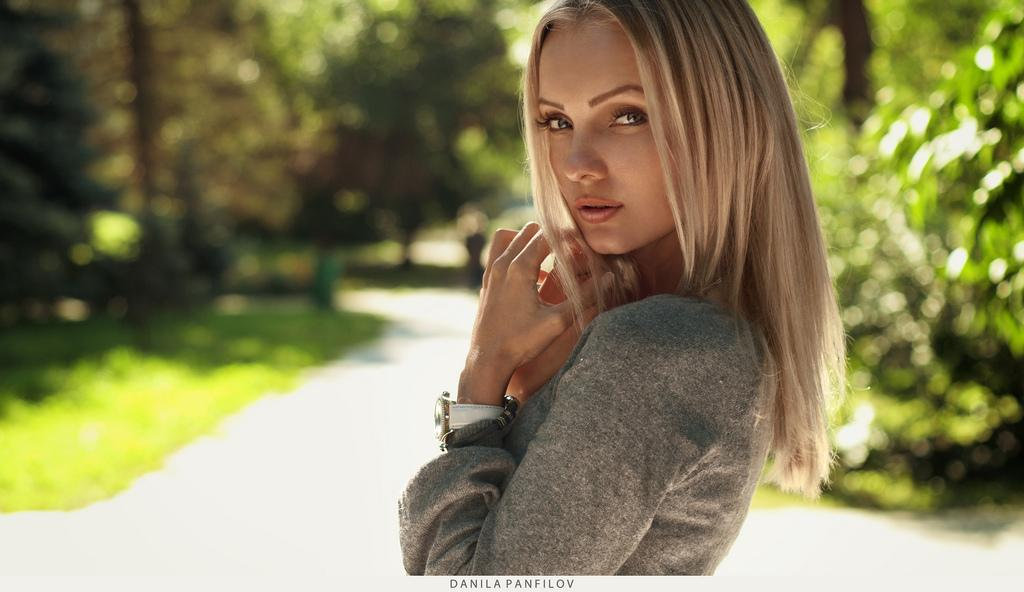Who is the main subject in the image? There is a girl in the image. Where is the girl positioned in the image? The girl is standing in the center of the image. What can be seen in the background of the image? There is greenery in the background of the image. How many geese are flying over the girl's head in the image? There are no geese present in the image. What type of heart-shaped object can be seen in the girl's hand in the image? There is no heart-shaped object visible in the girl's hand in the image. 